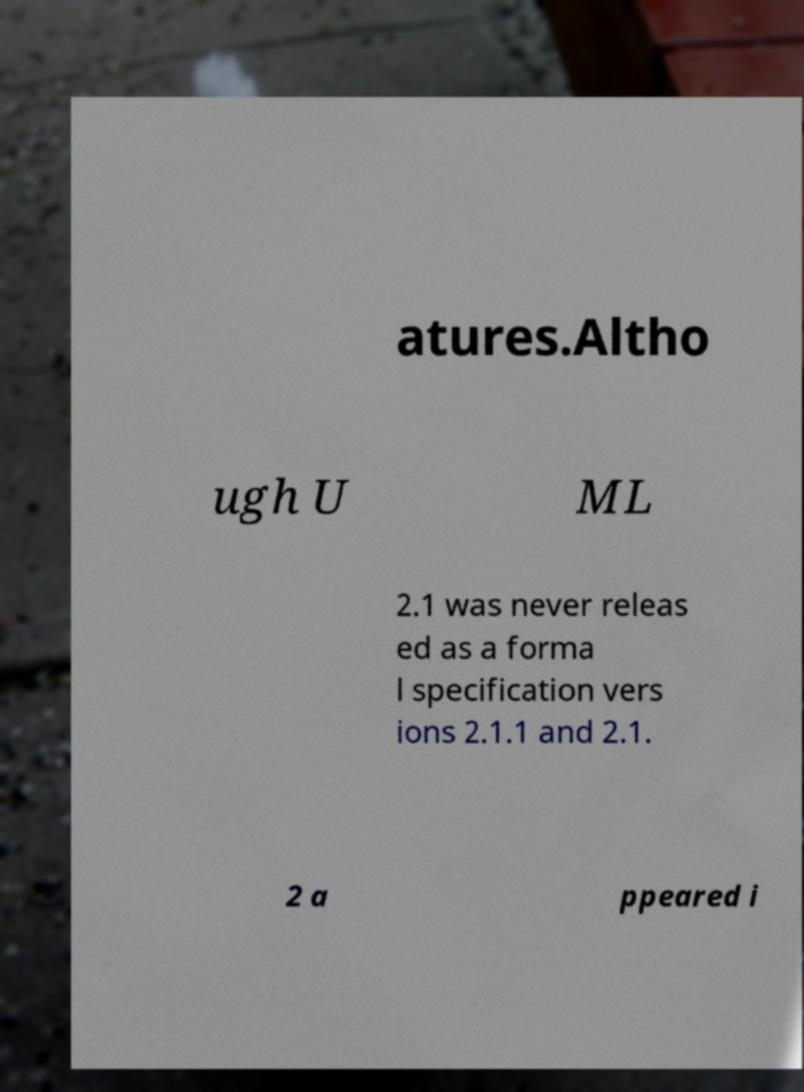Can you read and provide the text displayed in the image?This photo seems to have some interesting text. Can you extract and type it out for me? atures.Altho ugh U ML 2.1 was never releas ed as a forma l specification vers ions 2.1.1 and 2.1. 2 a ppeared i 